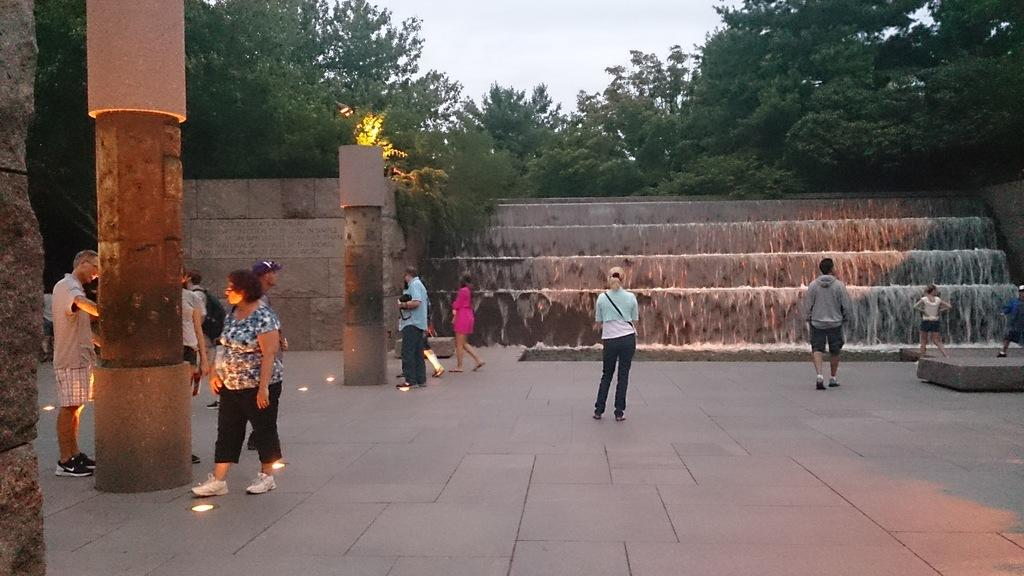Where was the image taken? The image was clicked outside. What can be seen at the top of the image? There are trees and sky visible at the top of the image. What is the main feature in the middle of the image? There are waterfalls in the middle of the image. Are there any people present in the image? Yes, there are people standing in the middle of the image. What type of chair is present in the image? There is no chair present in the image. 